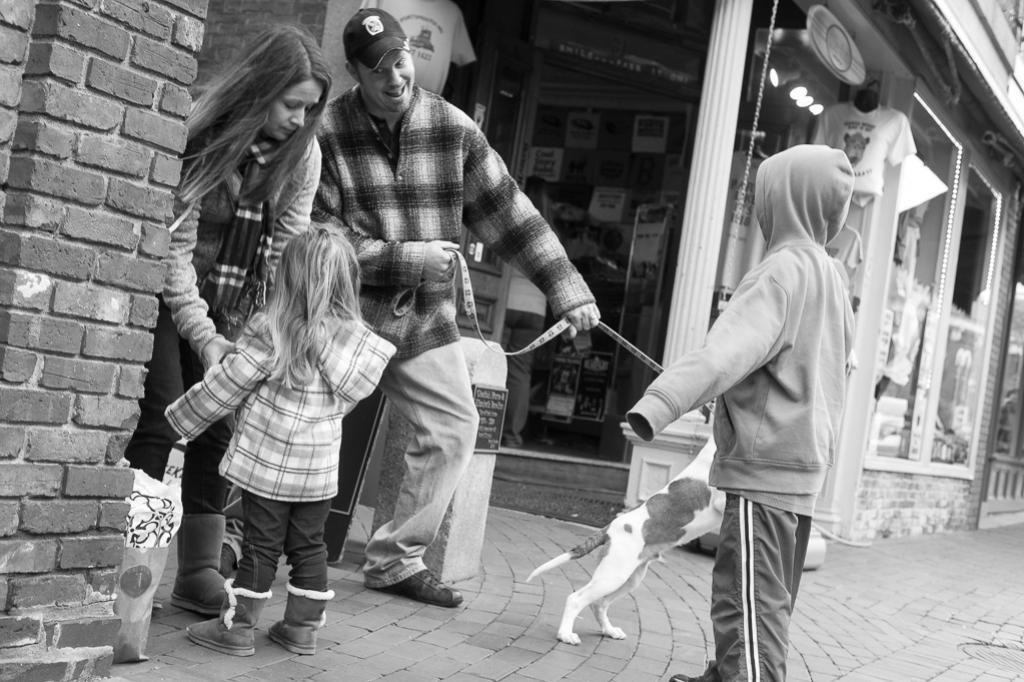How many individuals are present in the image? There are four people in the image. What other living creature can be seen in the image? There is a cat in the image. Where are the people and cat located? They are standing on a road in the image. What is on the left side of the image? There is a brick wall on the left side of the image. What type of structure is visible in the image? There is a building in the image. What type of riddle is the cat solving in the image? There is no riddle present in the image, nor is the cat solving one. 